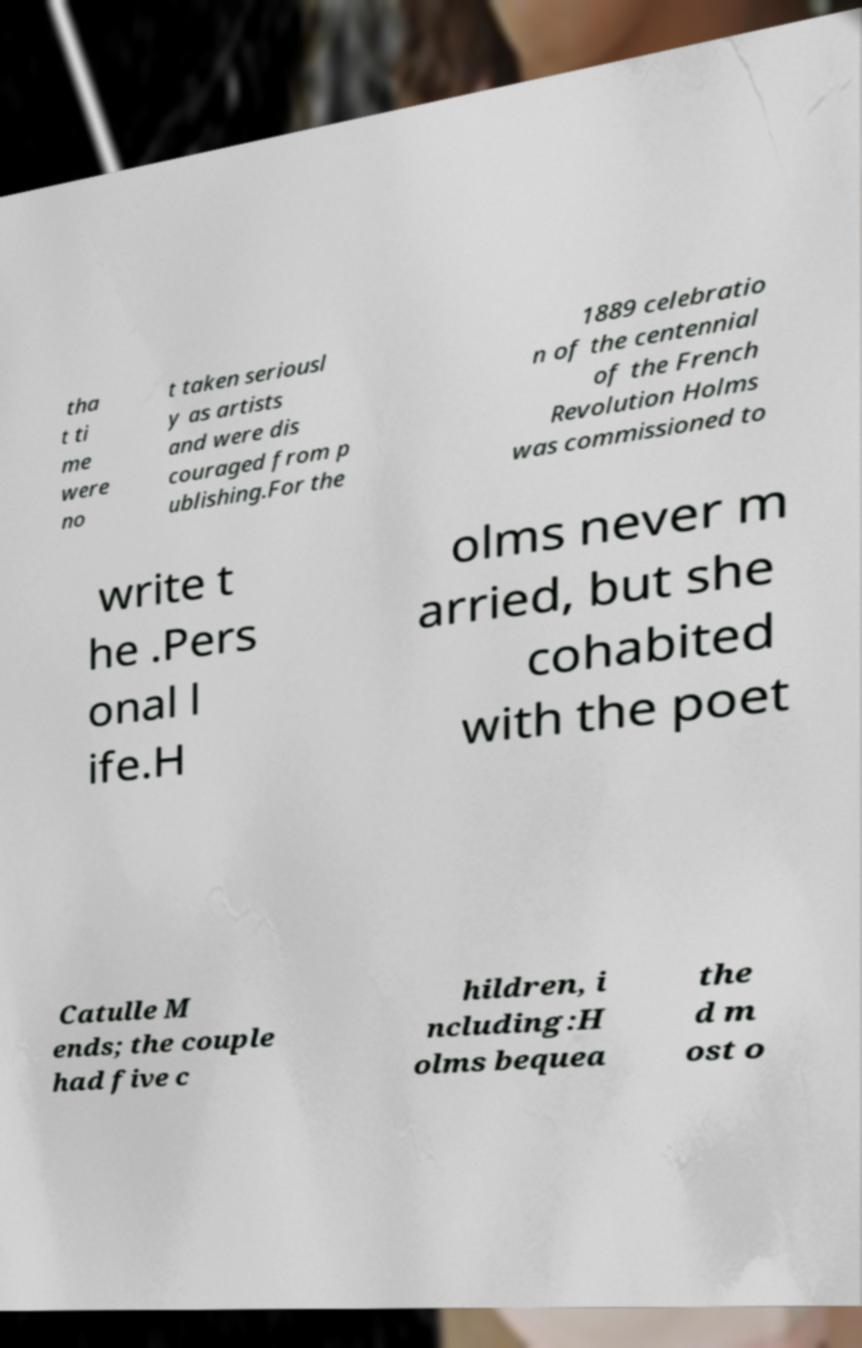Please read and relay the text visible in this image. What does it say? tha t ti me were no t taken seriousl y as artists and were dis couraged from p ublishing.For the 1889 celebratio n of the centennial of the French Revolution Holms was commissioned to write t he .Pers onal l ife.H olms never m arried, but she cohabited with the poet Catulle M ends; the couple had five c hildren, i ncluding:H olms bequea the d m ost o 